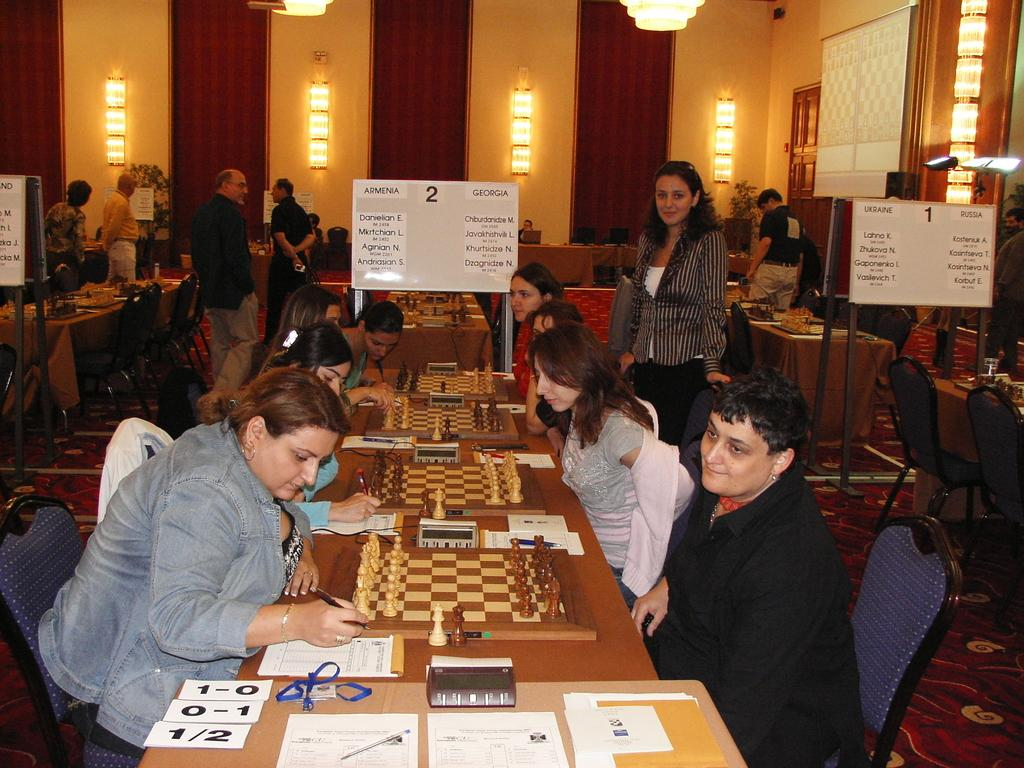What type of space is depicted in the image? There is a room in the image. What furniture is present in the room? The room contains chairs and benches. What activity is taking place in the room? People are playing chess in the room. How can the progress of the game be tracked in the image? There is a notice board displaying the score of the game. How does the fog affect the visibility of the chess boards in the image? There is no fog present in the image; it is an indoor setting with clear visibility of the chess boards. 